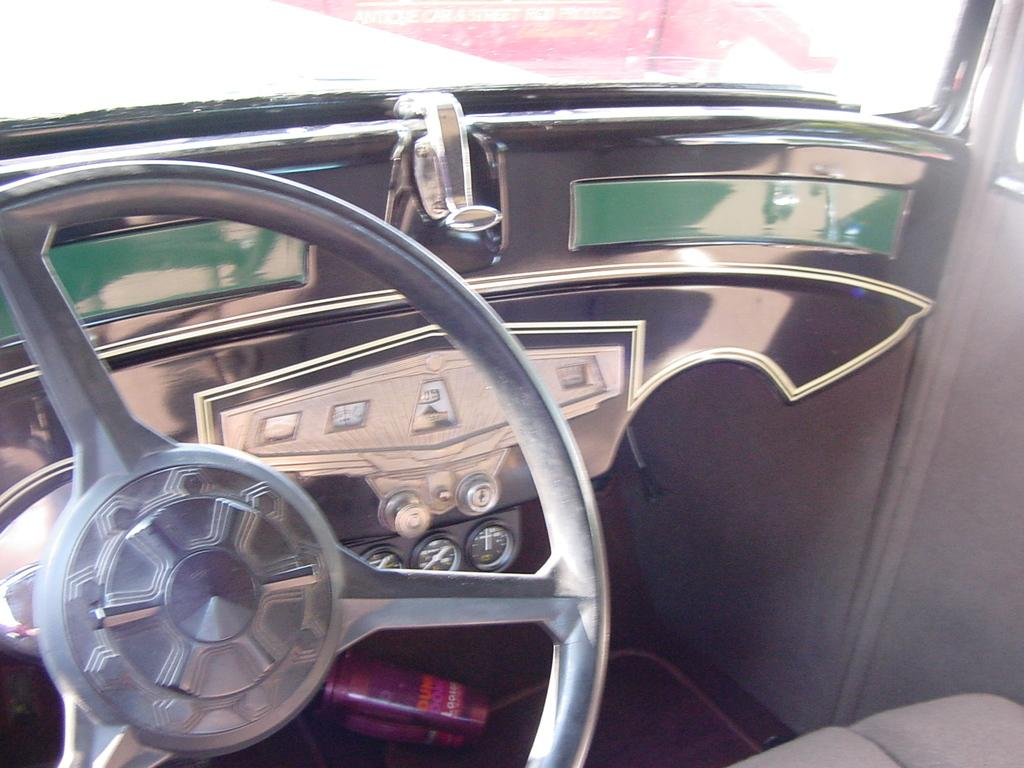What is the main subject of the image? The main subject of the image is a vehicle. What feature is present in the vehicle for controlling its direction? The vehicle has a steering wheel for controlling its direction. What devices are present in the vehicle for displaying information? The vehicle has electronic meters for displaying information. What is provided in the vehicle for the driver or passengers to sit on? The vehicle has a seat for sitting. What type of crack can be seen on the windshield of the vehicle in the image? There is no crack visible on the windshield of the vehicle in the image. What song is being played in the vehicle in the image? There is no information about any music or songs being played in the vehicle in the image. 